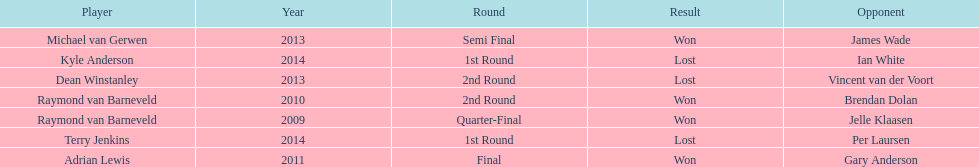Who won the first world darts championship? Raymond van Barneveld. 